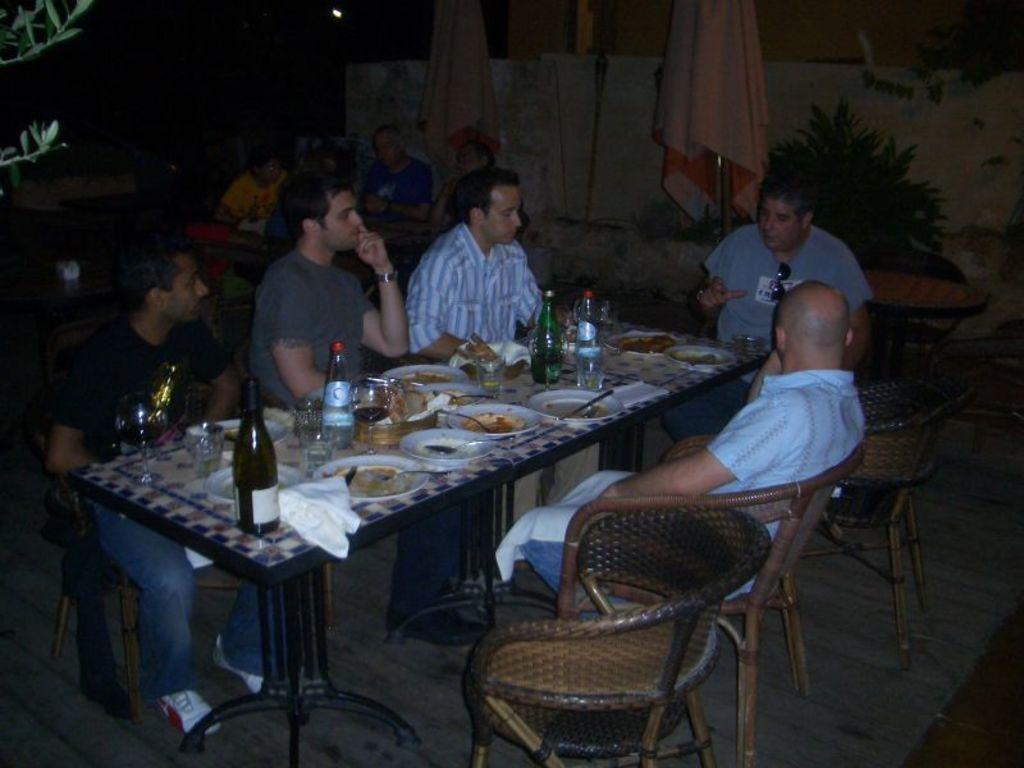In one or two sentences, can you explain what this image depicts? Here we can see a group of people sitting on chairs with table present in front of them having food and bottle of wine present on it 